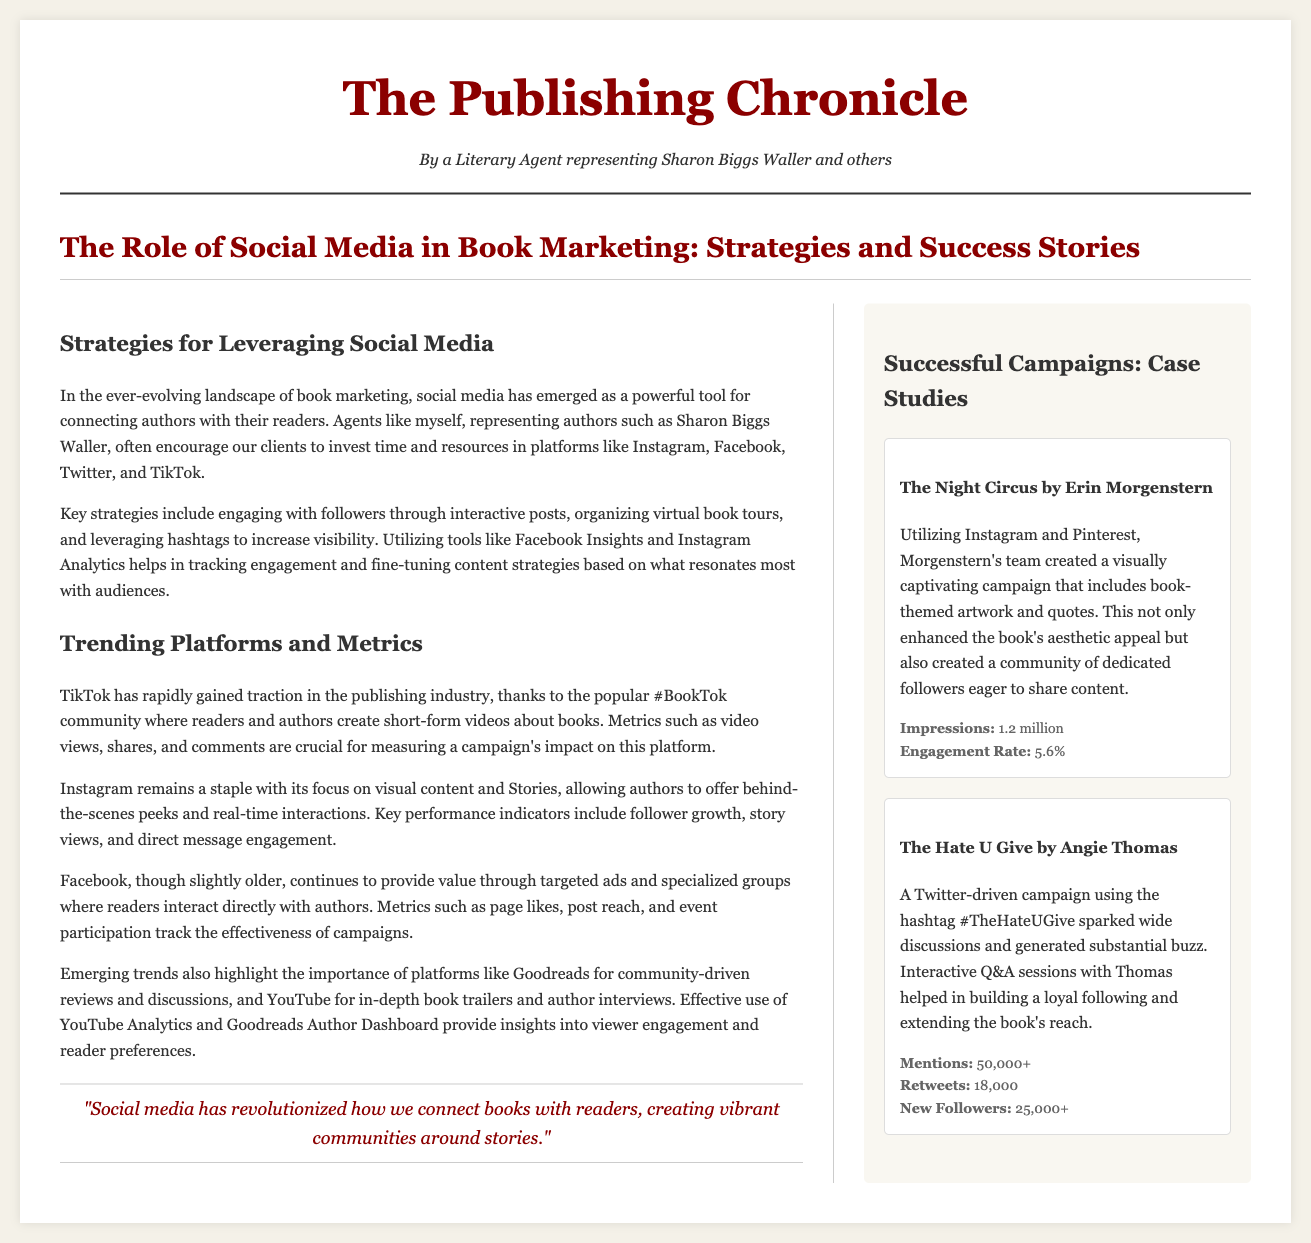What is the primary role of social media in book marketing? The document states that social media has emerged as a powerful tool for connecting authors with their readers.
Answer: Connecting authors with readers Which platform has gained traction through the #BookTok community? The document mentions TikTok as rapidly gaining traction in the publishing industry due to this community.
Answer: TikTok How many impressions did the campaign for "The Night Circus" generate? The case study indicates that the campaign generated 1.2 million impressions.
Answer: 1.2 million What was the engagement rate for "The Night Circus"? The document notes an engagement rate of 5.6%.
Answer: 5.6% What social media strategy was used for "The Hate U Give"? The document states that a Twitter-driven campaign was implemented using the hashtag #TheHateUGive.
Answer: Twitter-driven campaign Which metrics are important for measuring impact on Instagram? The document lists key performance indicators such as follower growth, story views, and direct message engagement.
Answer: Follower growth, story views, direct message engagement What is one of the strategies highlighted for leveraging social media? The document mentions organizing virtual book tours as a key strategy.
Answer: Organizing virtual book tours Which community-driven site is noted for reviews and discussions? The document highlights Goodreads for community-driven reviews and discussions.
Answer: Goodreads 